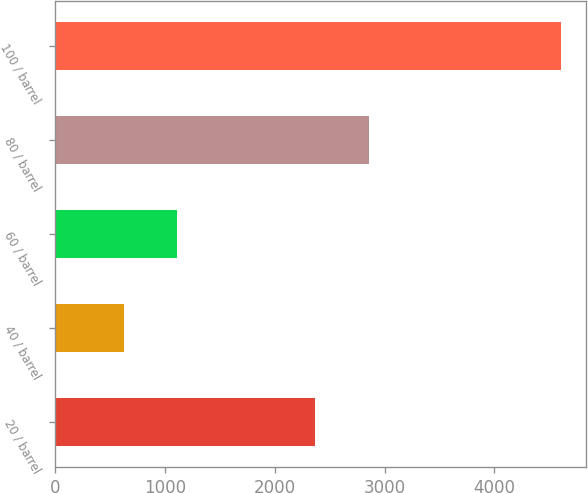<chart> <loc_0><loc_0><loc_500><loc_500><bar_chart><fcel>20 / barrel<fcel>40 / barrel<fcel>60 / barrel<fcel>80 / barrel<fcel>100 / barrel<nl><fcel>2371<fcel>628<fcel>1115<fcel>2858<fcel>4602<nl></chart> 